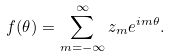Convert formula to latex. <formula><loc_0><loc_0><loc_500><loc_500>f ( \theta ) = \sum _ { m = - \infty } ^ { \infty } z _ { m } e ^ { i m \theta } .</formula> 